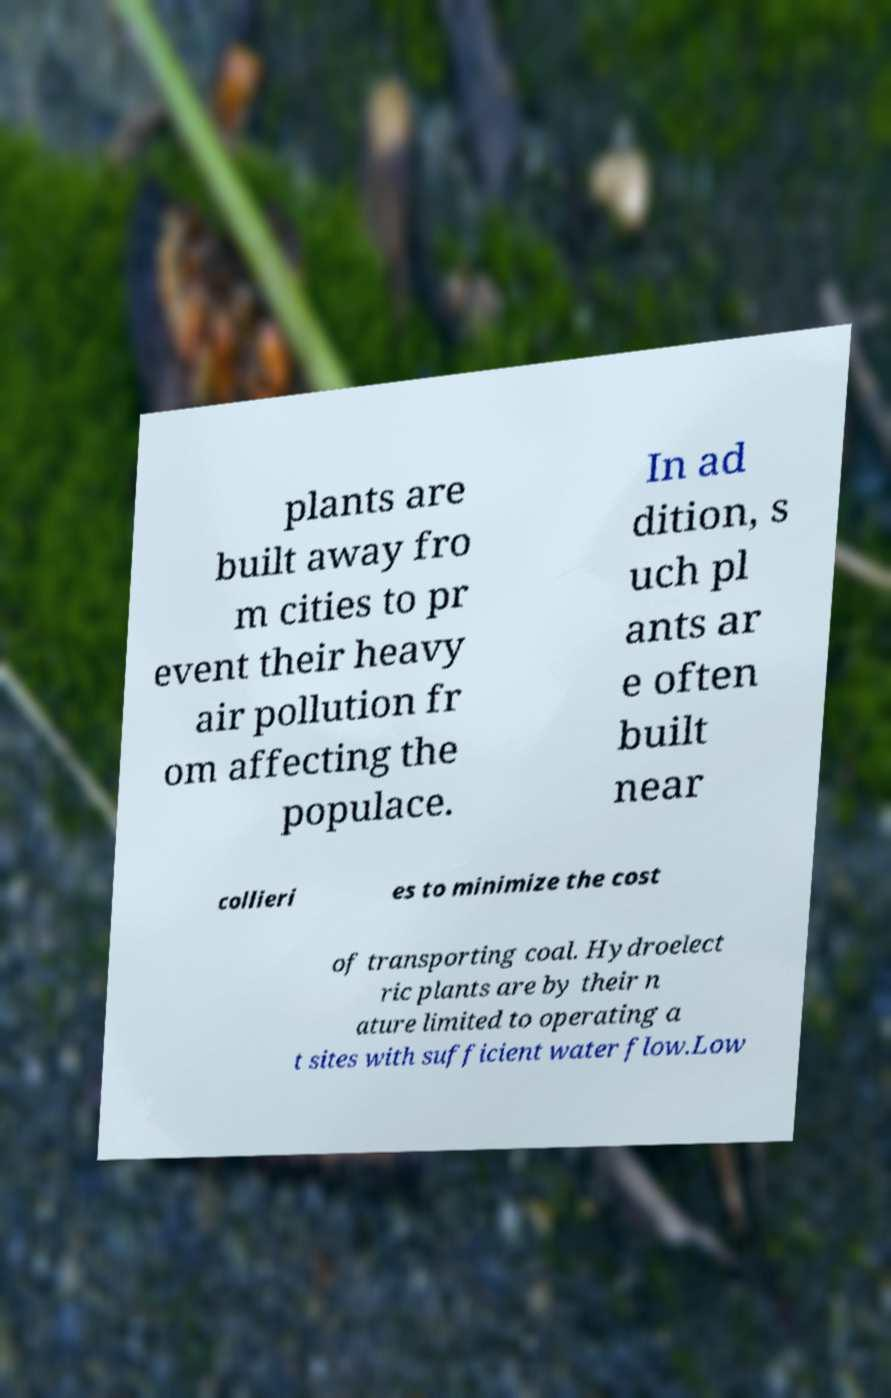What messages or text are displayed in this image? I need them in a readable, typed format. plants are built away fro m cities to pr event their heavy air pollution fr om affecting the populace. In ad dition, s uch pl ants ar e often built near collieri es to minimize the cost of transporting coal. Hydroelect ric plants are by their n ature limited to operating a t sites with sufficient water flow.Low 